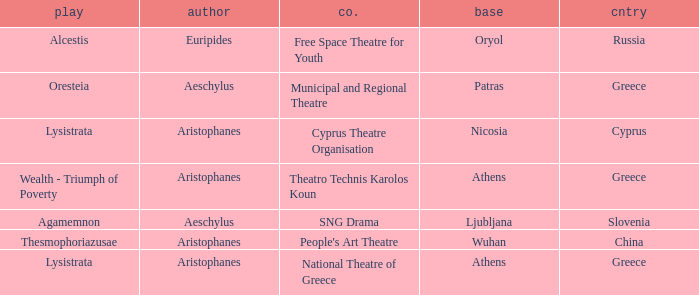What is the base when the play is thesmophoriazusae? Wuhan. 